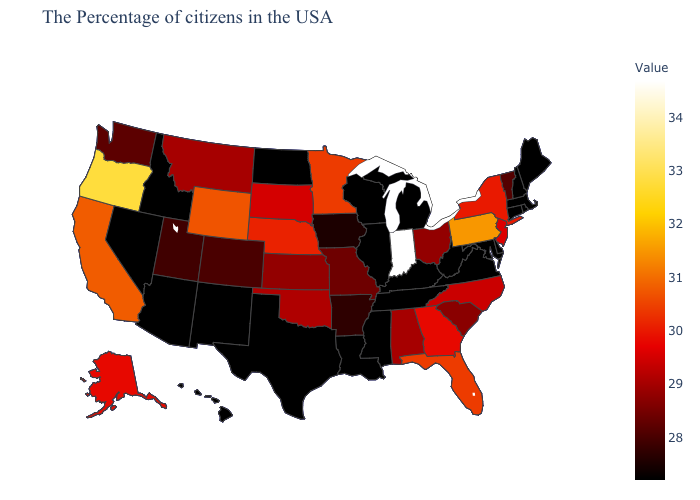Among the states that border Utah , does Arizona have the highest value?
Be succinct. No. Which states hav the highest value in the South?
Short answer required. Florida. Does Maryland have the lowest value in the South?
Keep it brief. Yes. Which states have the lowest value in the USA?
Write a very short answer. Maine, Massachusetts, Rhode Island, New Hampshire, Connecticut, Delaware, Maryland, Virginia, West Virginia, Michigan, Kentucky, Tennessee, Wisconsin, Illinois, Mississippi, Louisiana, Texas, North Dakota, New Mexico, Arizona, Idaho, Nevada, Hawaii. Among the states that border South Dakota , which have the highest value?
Give a very brief answer. Wyoming. Does Oregon have a higher value than Indiana?
Short answer required. No. 